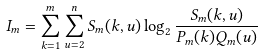<formula> <loc_0><loc_0><loc_500><loc_500>I _ { m } = \sum _ { k = 1 } ^ { m } \sum _ { u = 2 } ^ { n } S _ { m } ( k , u ) \log _ { 2 } \frac { S _ { m } ( k , u ) } { P _ { m } ( k ) Q _ { m } ( u ) }</formula> 